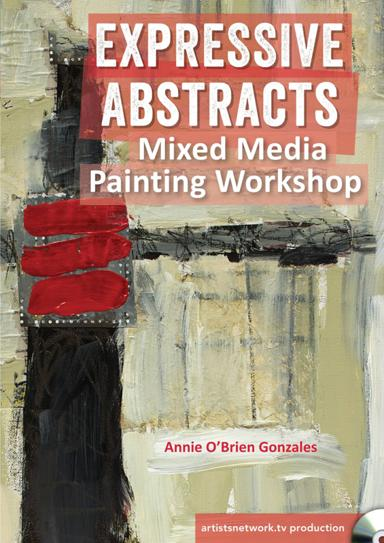What is the name of the mixed media painting workshop mentioned in the image? The workshop advertised in the image is titled "Expressive Abstracts Mixed Media Painting Workshop". This workshop promises to delve into the techniques and artistry of abstract and mixed-media painting, facilitated by renowned artist Annie O'Brien Gonzales. 